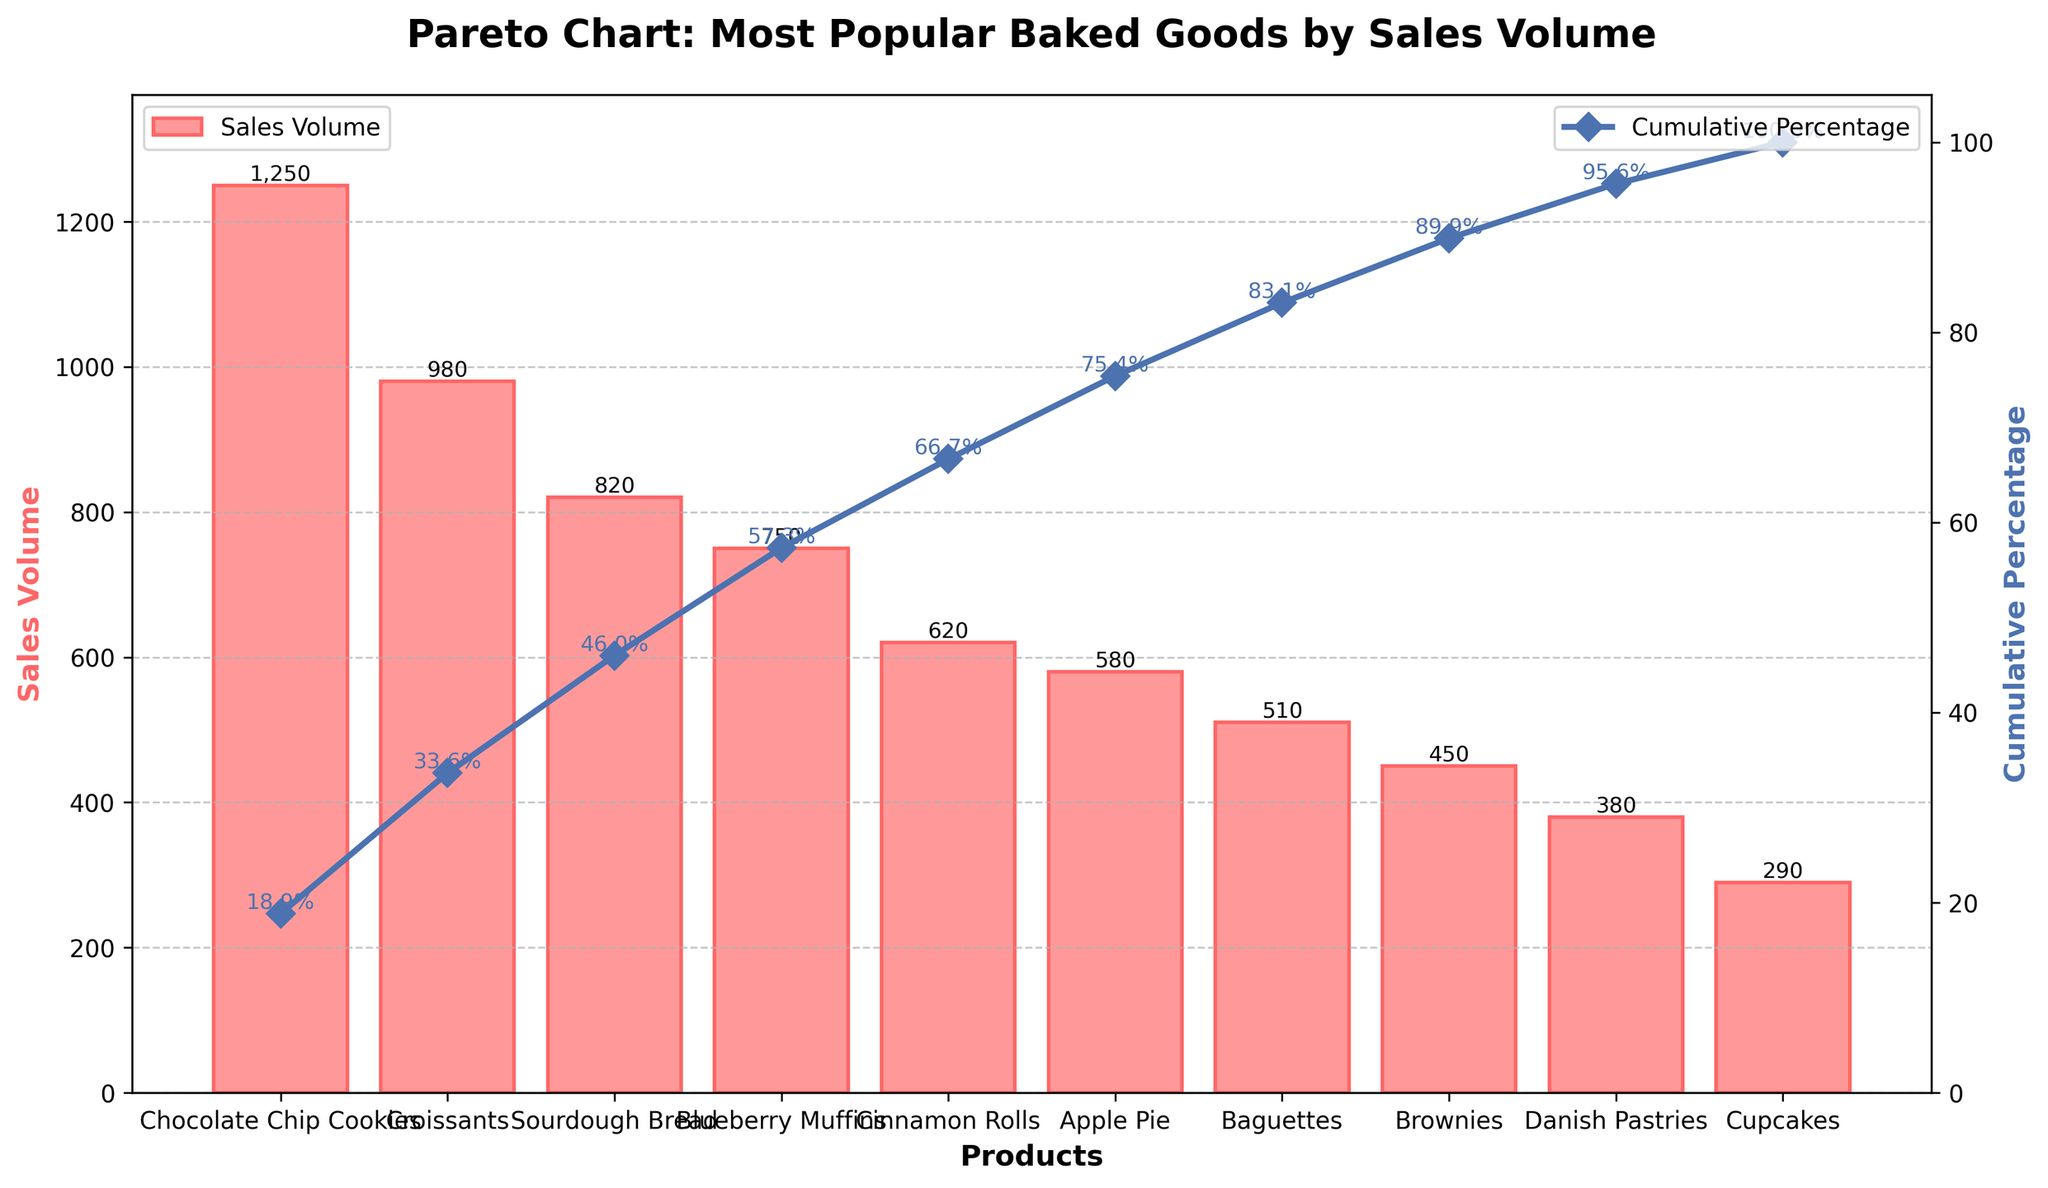What is the title of the chart? The title of the chart is given at the top of the figure and typically describes the content of the chart. In this case, it focuses on the most popular baked goods in the bakery ranked by sales volume.
Answer: Pareto Chart: Most Popular Baked Goods by Sales Volume What product has the highest sales volume? To find the product with the highest sales volume, look for the tallest bar in the bar chart.
Answer: Chocolate Chip Cookies What is the cumulative percentage of sales for the top three products? Add the cumulative percentage of the top three products from the line chart. The cumulative percentages for Chocolate Chip Cookies, Croissants, and Sourdough Bread are given next to the markers on the line.
Answer: 55.9% Which product has the lowest sales volume? Identify the shortest bar in the bar chart, which corresponds to the product with the lowest sales volume.
Answer: Cupcakes What is the total sales volume for the top five products? Sum the sales volumes of the top five products: Chocolate Chip Cookies (1250), Croissants (980), Sourdough Bread (820), Blueberry Muffins (750), and Cinnamon Rolls (620). The total is 1250 + 980 + 820 + 750 + 620.
Answer: 4420 What percentage of the total sales volume is contributed by Croissants alone? Divide the sales volume of Croissants (980) by the total sales volume of all products and multiply by 100. First, sum all sales volumes: 7200. Then calculate (980 / 7200) * 100.
Answer: 13.6% Which product marked the highest jump in cumulative percentage from the previous product? Look at the cumulative percentage values for each product and identify the largest difference between consecutive products. From Chocolate Chip Cookies to Croissants, the jump is from 17.4% to 31.9% (14.5%). None of the other jumps exceed this.
Answer: Croissants (from Chocolate Chip Cookies) What is the difference in sales volume between Sourdough Bread and Brownies? Subtract the sales volume of Brownies (450) from the sales volume of Sourdough Bread (820).
Answer: 370 How many products have a sales volume greater than 500? Count the number of bars that exceed the 500 mark on the y-axis.
Answer: 6 products At what cumulative percentage do sales volumes start tapering off significantly? Observe the line chart and identify where the slope starts to decrease sharply. The line flattens out prominently after Blueberry Muffins, which corresponds to around 72%.
Answer: Around 72% 